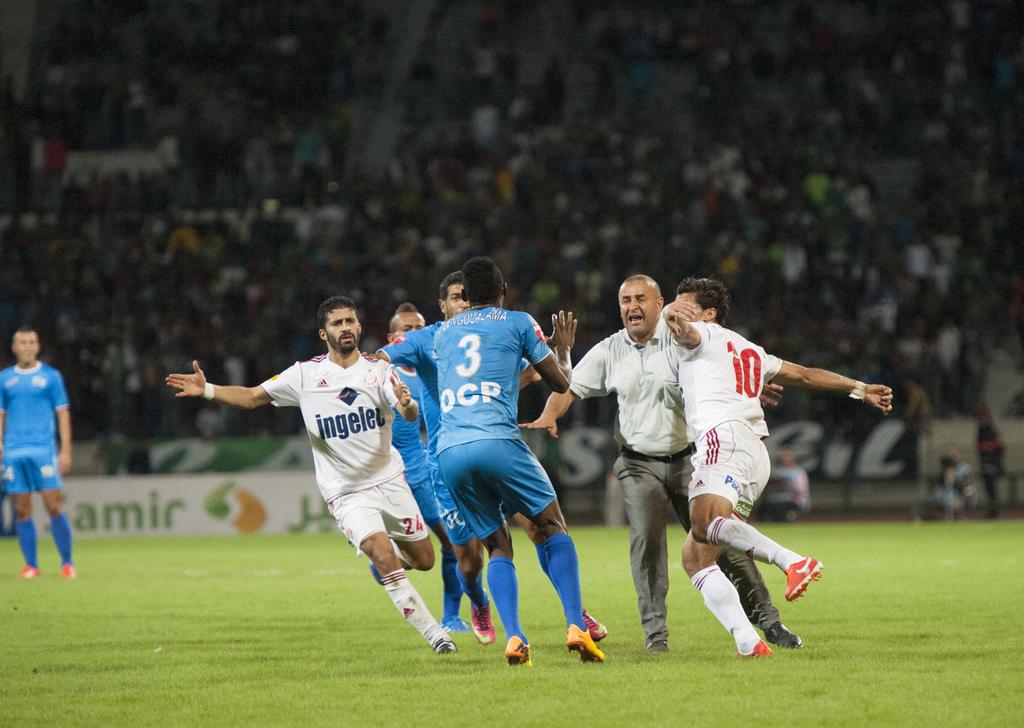What number is the blue shirt player?
Your answer should be compact. 3. 